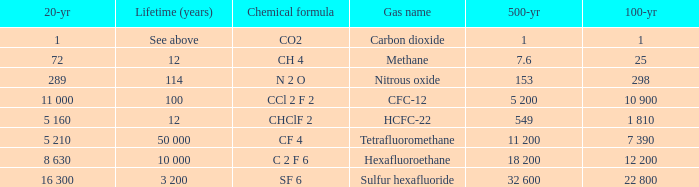What is the 100 year for Carbon Dioxide? 1.0. 